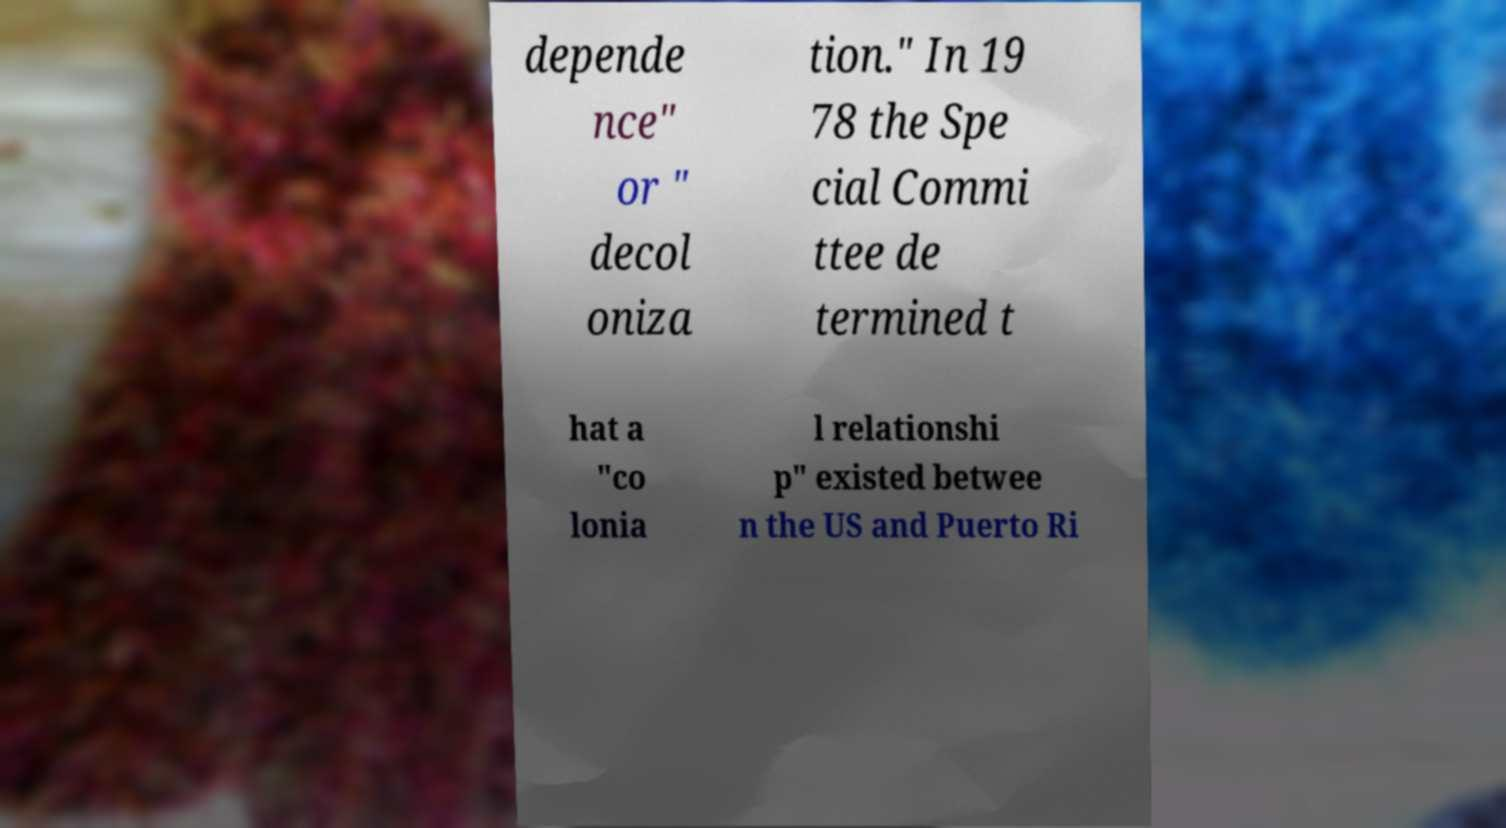Can you read and provide the text displayed in the image?This photo seems to have some interesting text. Can you extract and type it out for me? depende nce" or " decol oniza tion." In 19 78 the Spe cial Commi ttee de termined t hat a "co lonia l relationshi p" existed betwee n the US and Puerto Ri 